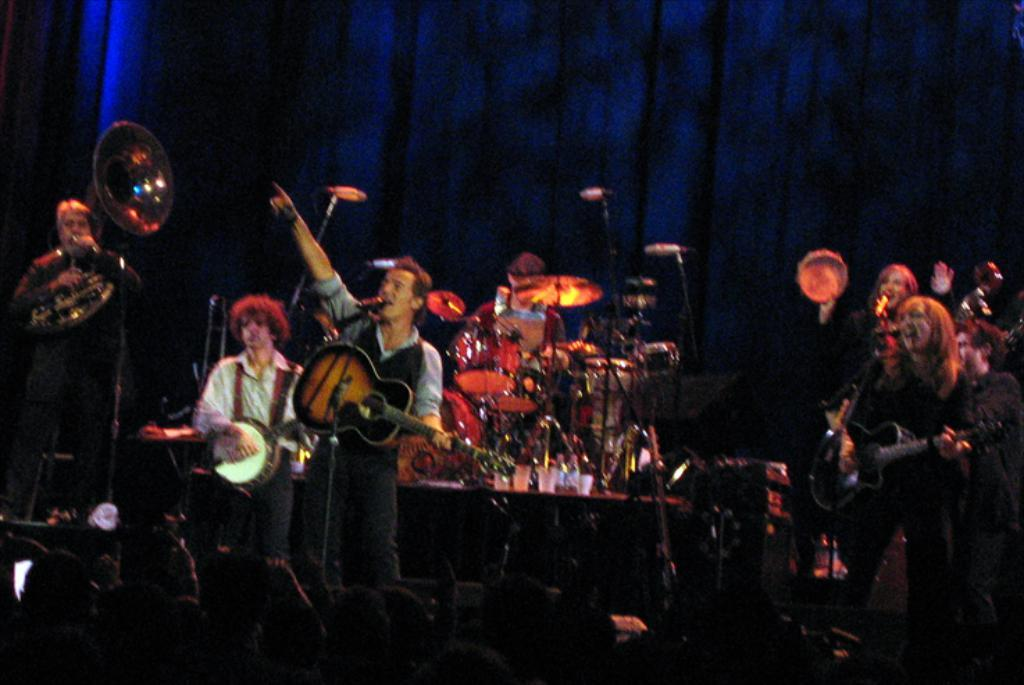What is happening in the image? There is a group of people in the image, and they are performing musical instruments. How many people are in the group? The number of people in the group is not specified, but there is a group of people present. What type of instruments are the people playing? The specific instruments being played are not mentioned, but the people are performing musical instruments. What type of zipper can be seen on the canvas in the image? There is no mention of a zipper or canvas in the image; it features a group of people performing musical instruments. 